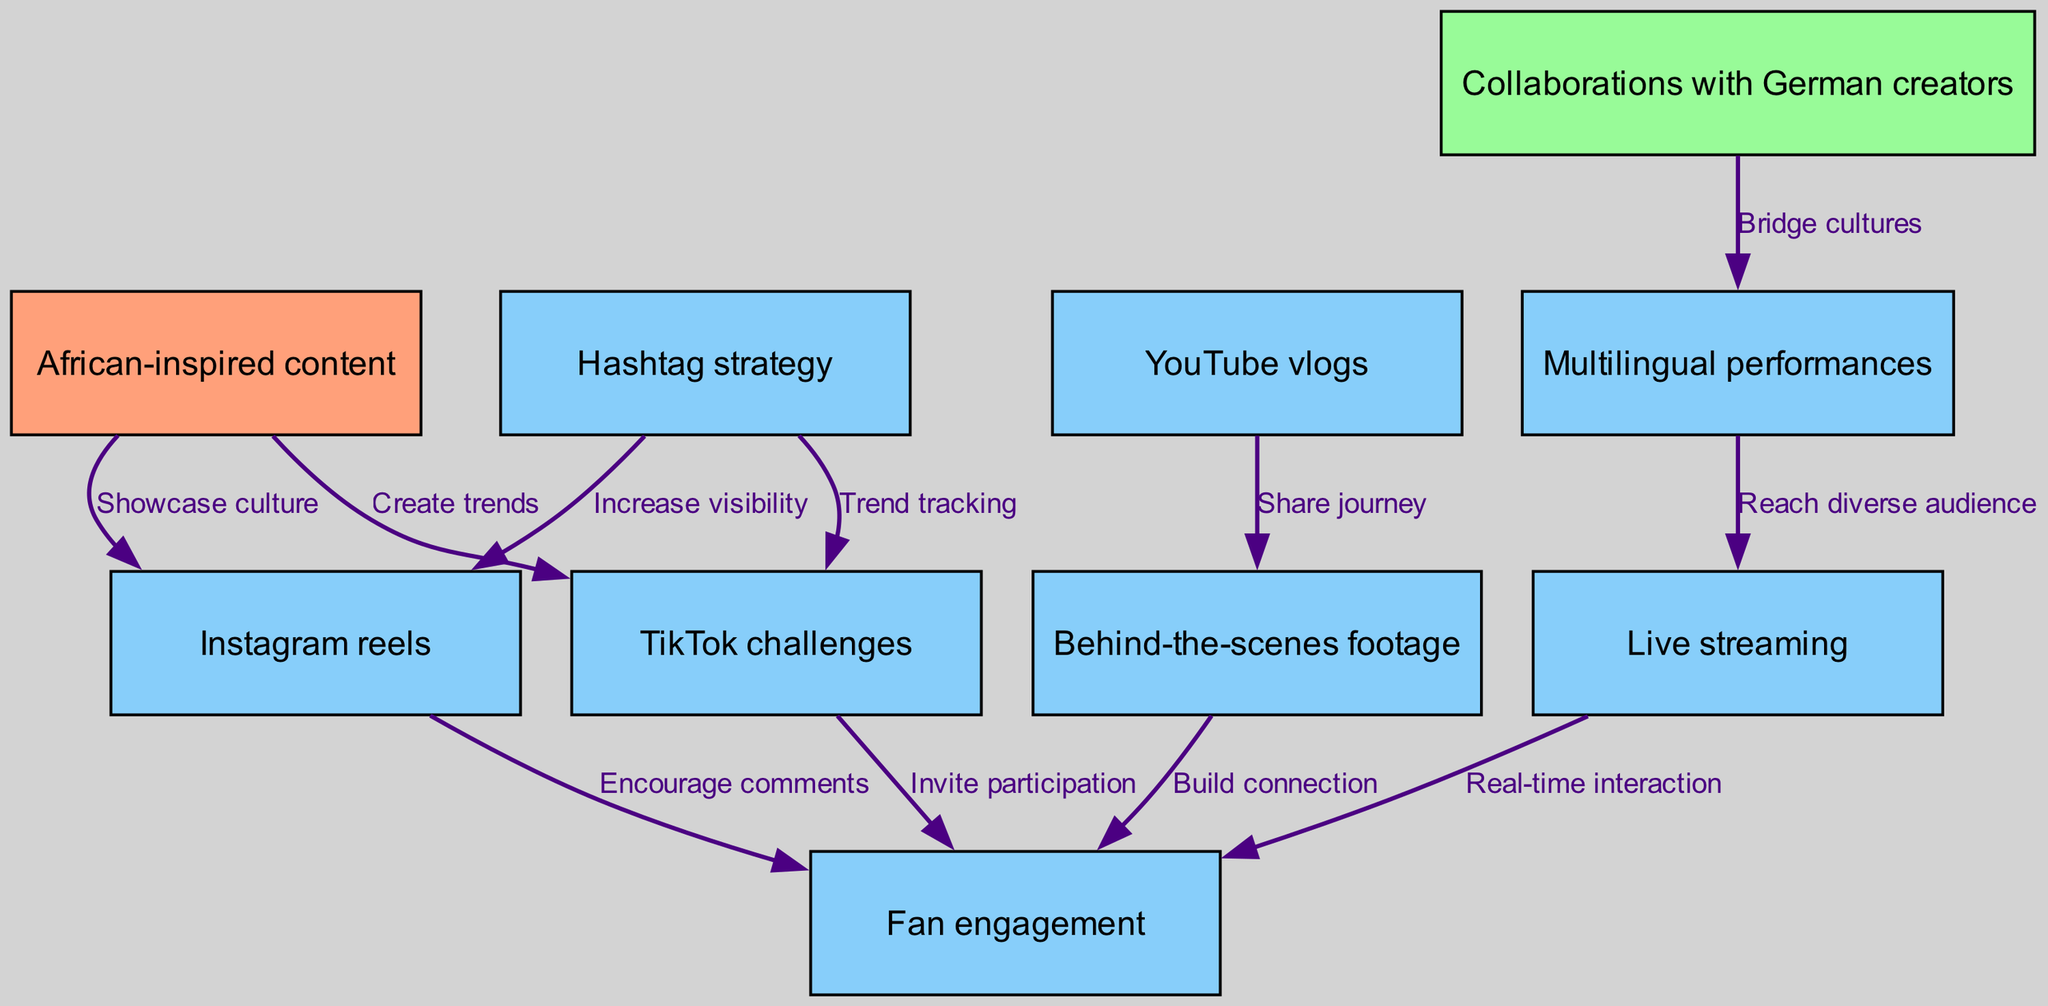What is the total number of nodes in the diagram? Counting the entries in the nodes list from the data, there are ten distinct nodes, representing different content types and engagement strategies.
Answer: 10 Which node represents the strategy to encourage comments on other platforms? The edge leading from "Instagram reels" to "Fan engagement" indicates that this strategy focuses on encouraging comments as an engagement strategy.
Answer: Instagram reels What is the relationship between "Hashtag strategy" and "TikTok challenges"? The edge from "Hashtag strategy" directly leads to "TikTok challenges", indicating that the slogan of hashtag strategy relates to trend tracking for TikTok challenges.
Answer: Trend tracking How many edges are connecting to the "Fan engagement" node? By examining the edges in the data, three edges connect to "Fan engagement": from "Instagram reels", "TikTok challenges", and "Behind-the-scenes footage", and "Live streaming".
Answer: 4 Which node is linked to "Collaborations with German creators"? The node "Multilingual performances" is directly linked to "Collaborations with German creators", showing how cultural bridging occurs through performance language.
Answer: Multilingual performances In what way does "Live streaming" enhance "Fan engagement"? "Live streaming" allows for real-time interaction with fans, making it a direct way to strengthen engagement and connect with them instantly.
Answer: Real-time interaction Which type of content showcases culture according to the diagram? The node "African-inspired content" has an edge leading to "Instagram reels", illustrating that it showcases cultural elements through short videos.
Answer: African-inspired content What node appears as a prerequisite for "Behind-the-scenes footage"? "YouTube vlogs" are depicted as a precursor to "Behind-the-scenes footage," indicating that sharing the journey can provide behind-the-scenes access.
Answer: YouTube vlogs How does "Multilingual performances" benefit audience reach? The edge from "Multilingual performances" to "Live streaming" indicates that performing in multiple languages can help reach a more diverse audience effectively.
Answer: Reach diverse audience 